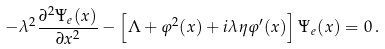<formula> <loc_0><loc_0><loc_500><loc_500>- \lambda ^ { 2 } \frac { \partial ^ { 2 } \Psi _ { e } ( x ) } { \partial x ^ { 2 } } - \left [ \Lambda + \varphi ^ { 2 } ( x ) + i \lambda \eta \varphi ^ { \prime } ( x ) \right ] \Psi _ { e } ( x ) = 0 \, .</formula> 